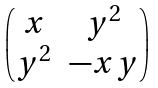Convert formula to latex. <formula><loc_0><loc_0><loc_500><loc_500>\begin{pmatrix} x & y ^ { 2 } \\ y ^ { 2 } & - x y \end{pmatrix}</formula> 